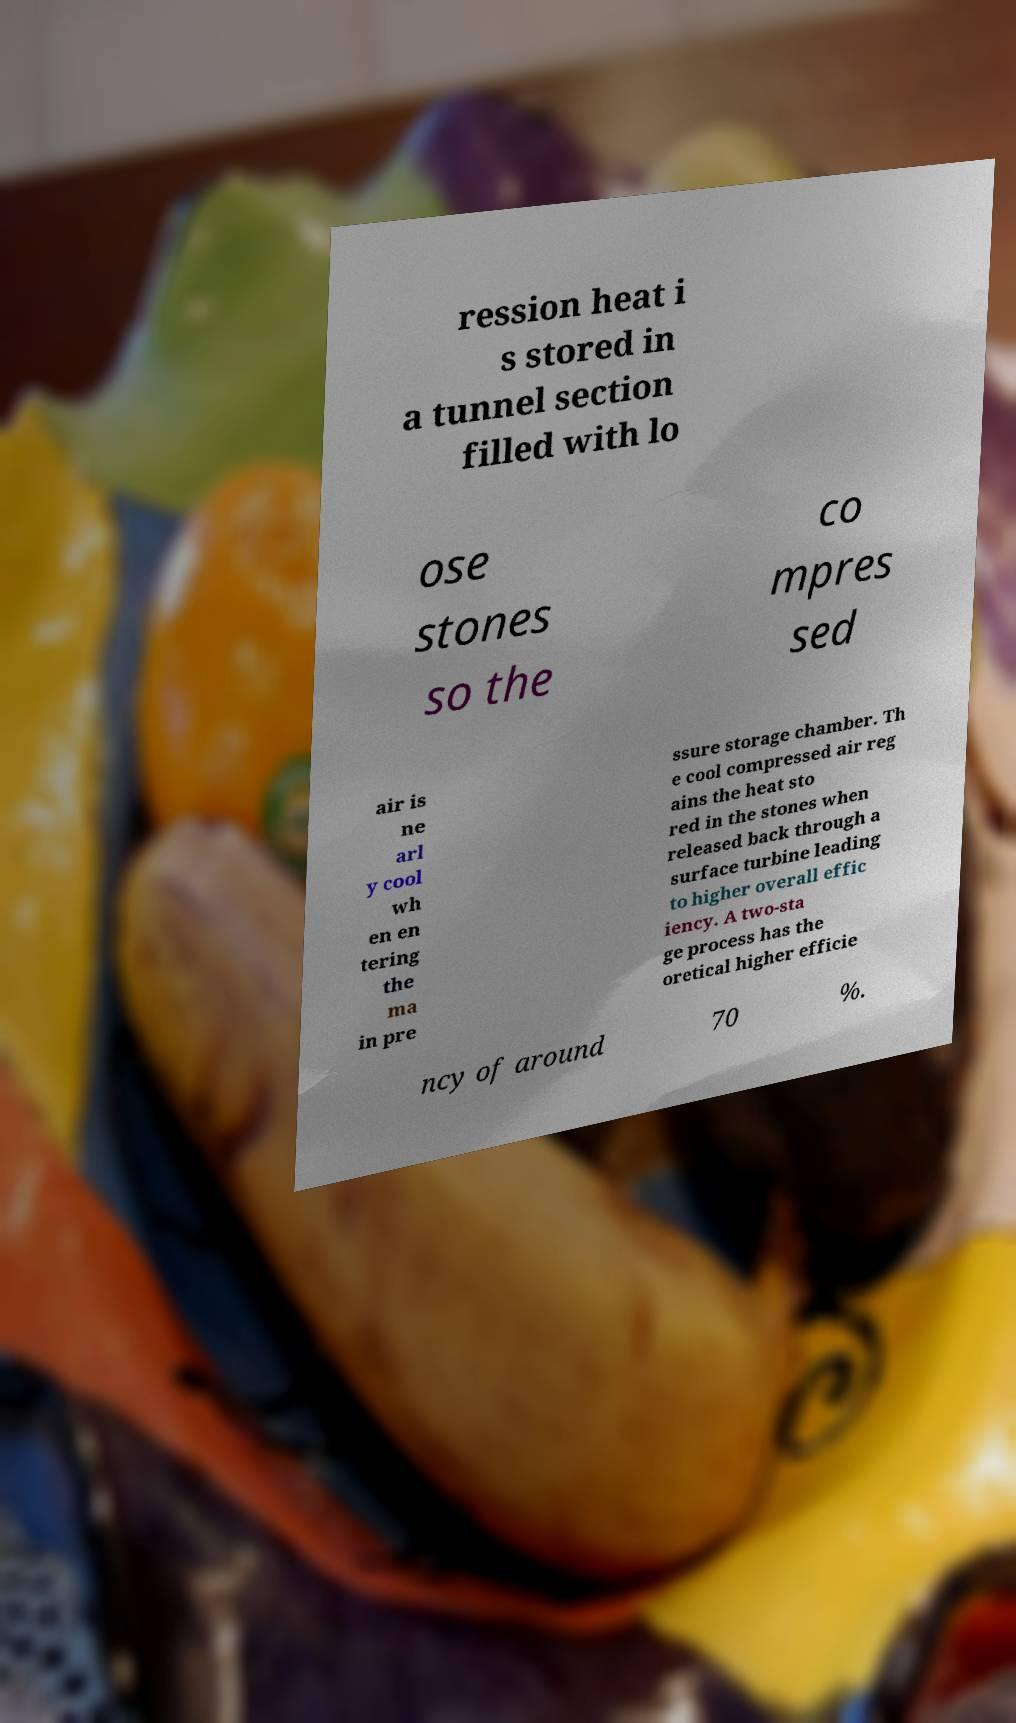Could you assist in decoding the text presented in this image and type it out clearly? ression heat i s stored in a tunnel section filled with lo ose stones so the co mpres sed air is ne arl y cool wh en en tering the ma in pre ssure storage chamber. Th e cool compressed air reg ains the heat sto red in the stones when released back through a surface turbine leading to higher overall effic iency. A two-sta ge process has the oretical higher efficie ncy of around 70 %. 